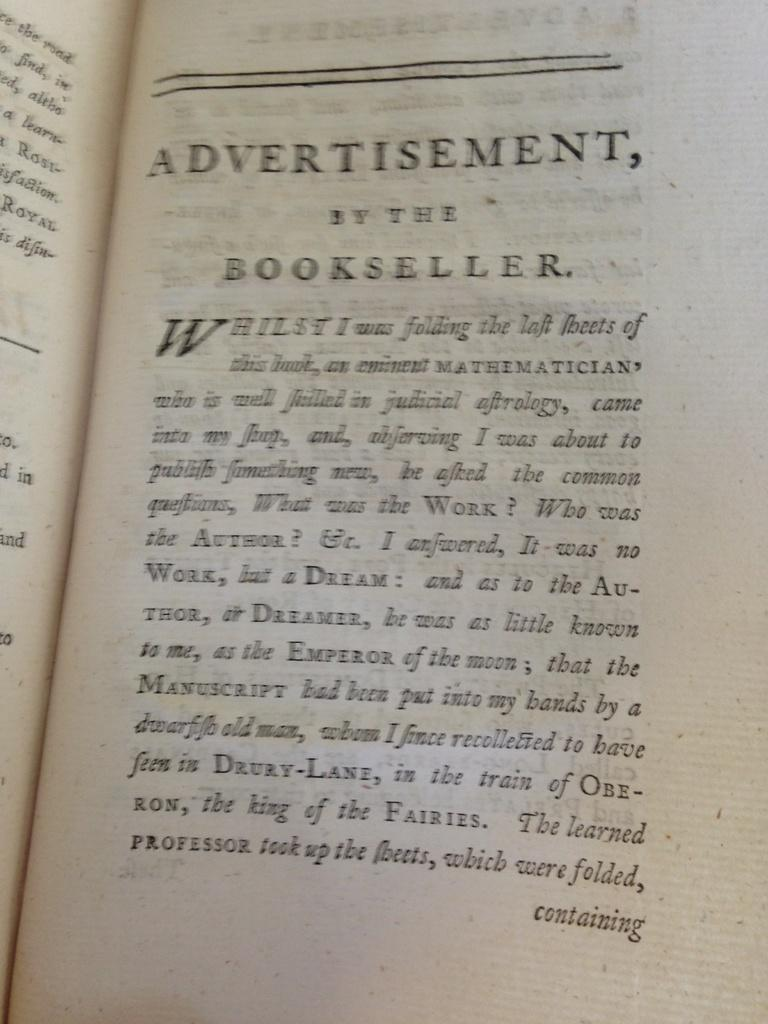<image>
Offer a succinct explanation of the picture presented. A page in a book that is titled Advertisement, by the bookseller. 